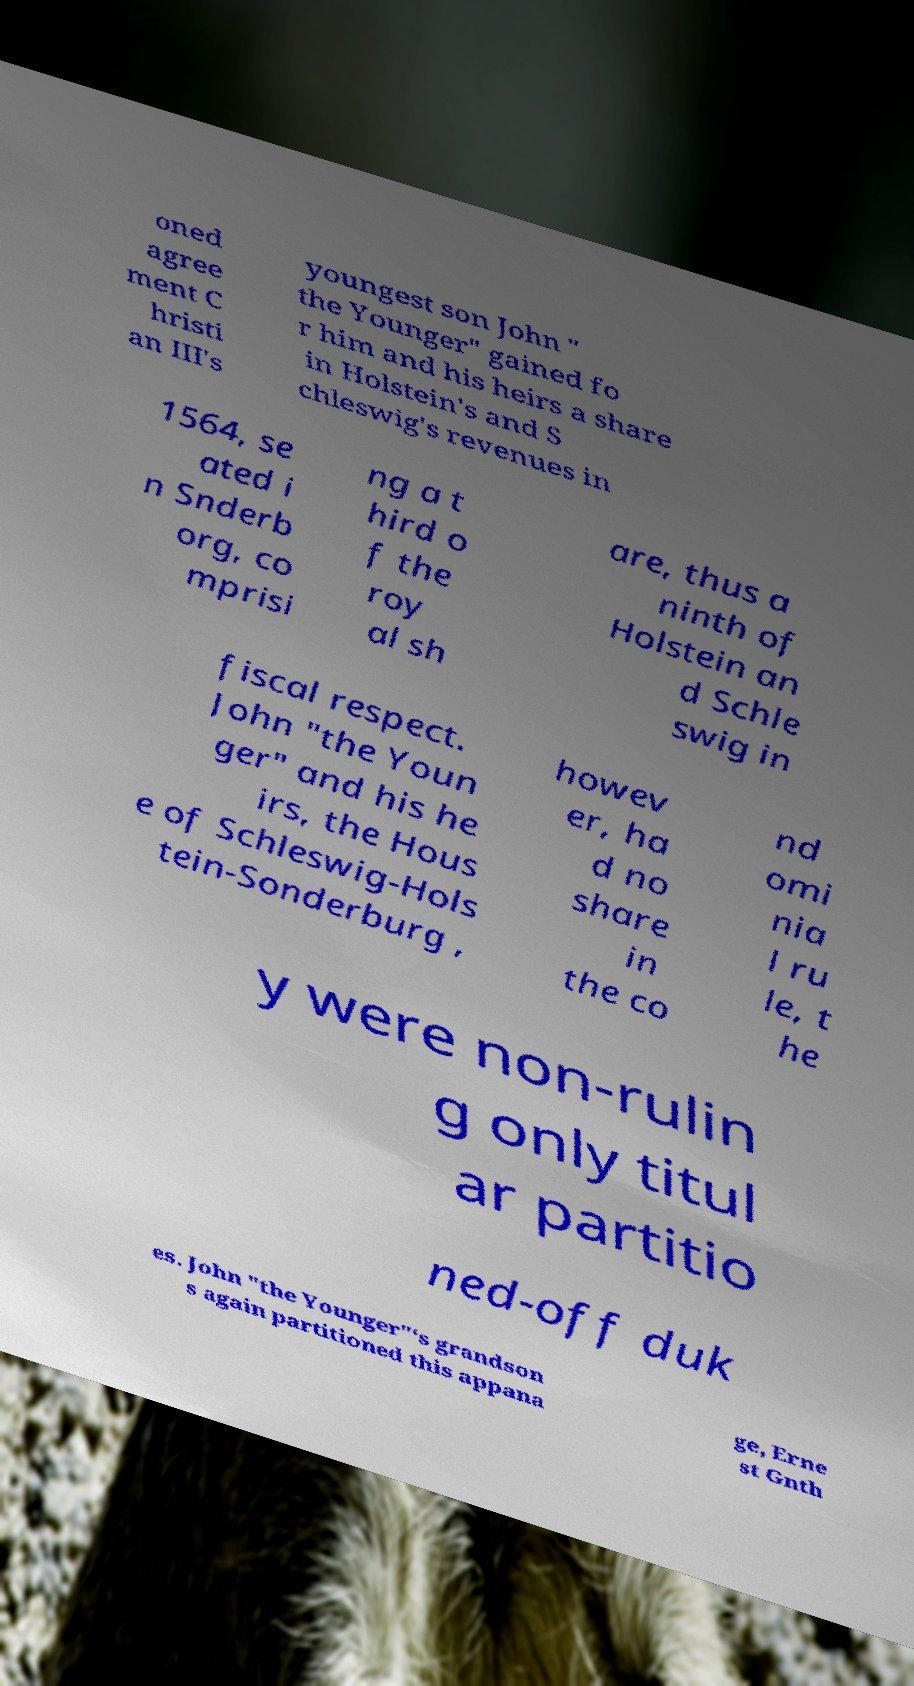Can you accurately transcribe the text from the provided image for me? oned agree ment C hristi an III's youngest son John " the Younger" gained fo r him and his heirs a share in Holstein's and S chleswig's revenues in 1564, se ated i n Snderb org, co mprisi ng a t hird o f the roy al sh are, thus a ninth of Holstein an d Schle swig in fiscal respect. John "the Youn ger" and his he irs, the Hous e of Schleswig-Hols tein-Sonderburg , howev er, ha d no share in the co nd omi nia l ru le, t he y were non-rulin g only titul ar partitio ned-off duk es. John "the Younger"‘s grandson s again partitioned this appana ge, Erne st Gnth 